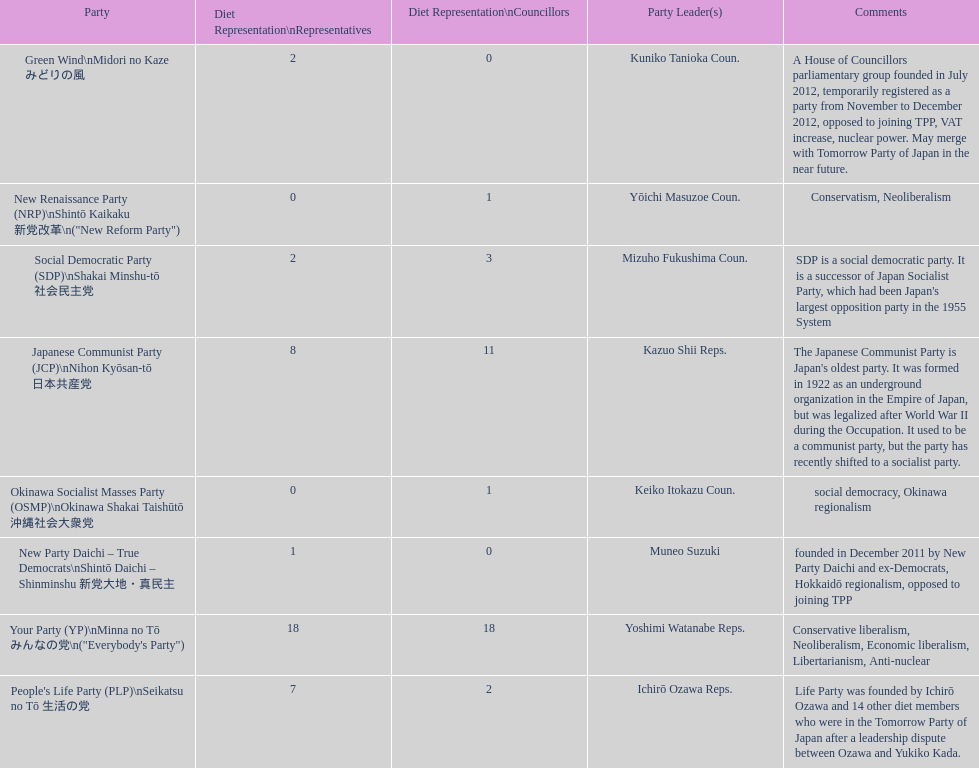People's life party has at most, how many party leaders? 1. 